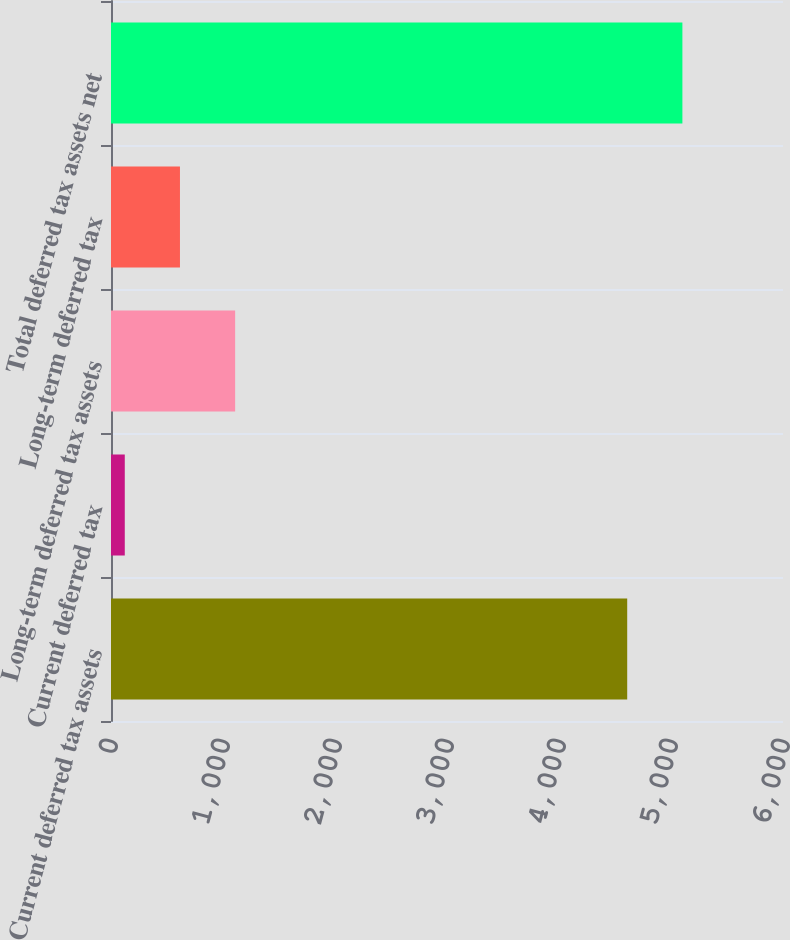Convert chart. <chart><loc_0><loc_0><loc_500><loc_500><bar_chart><fcel>Current deferred tax assets<fcel>Current deferred tax<fcel>Long-term deferred tax assets<fcel>Long-term deferred tax<fcel>Total deferred tax assets net<nl><fcel>4609<fcel>123<fcel>1108.4<fcel>615.7<fcel>5101.7<nl></chart> 